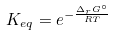<formula> <loc_0><loc_0><loc_500><loc_500>K _ { e q } = e ^ { - \frac { \Delta _ { r } G ^ { \circ } } { R T } }</formula> 